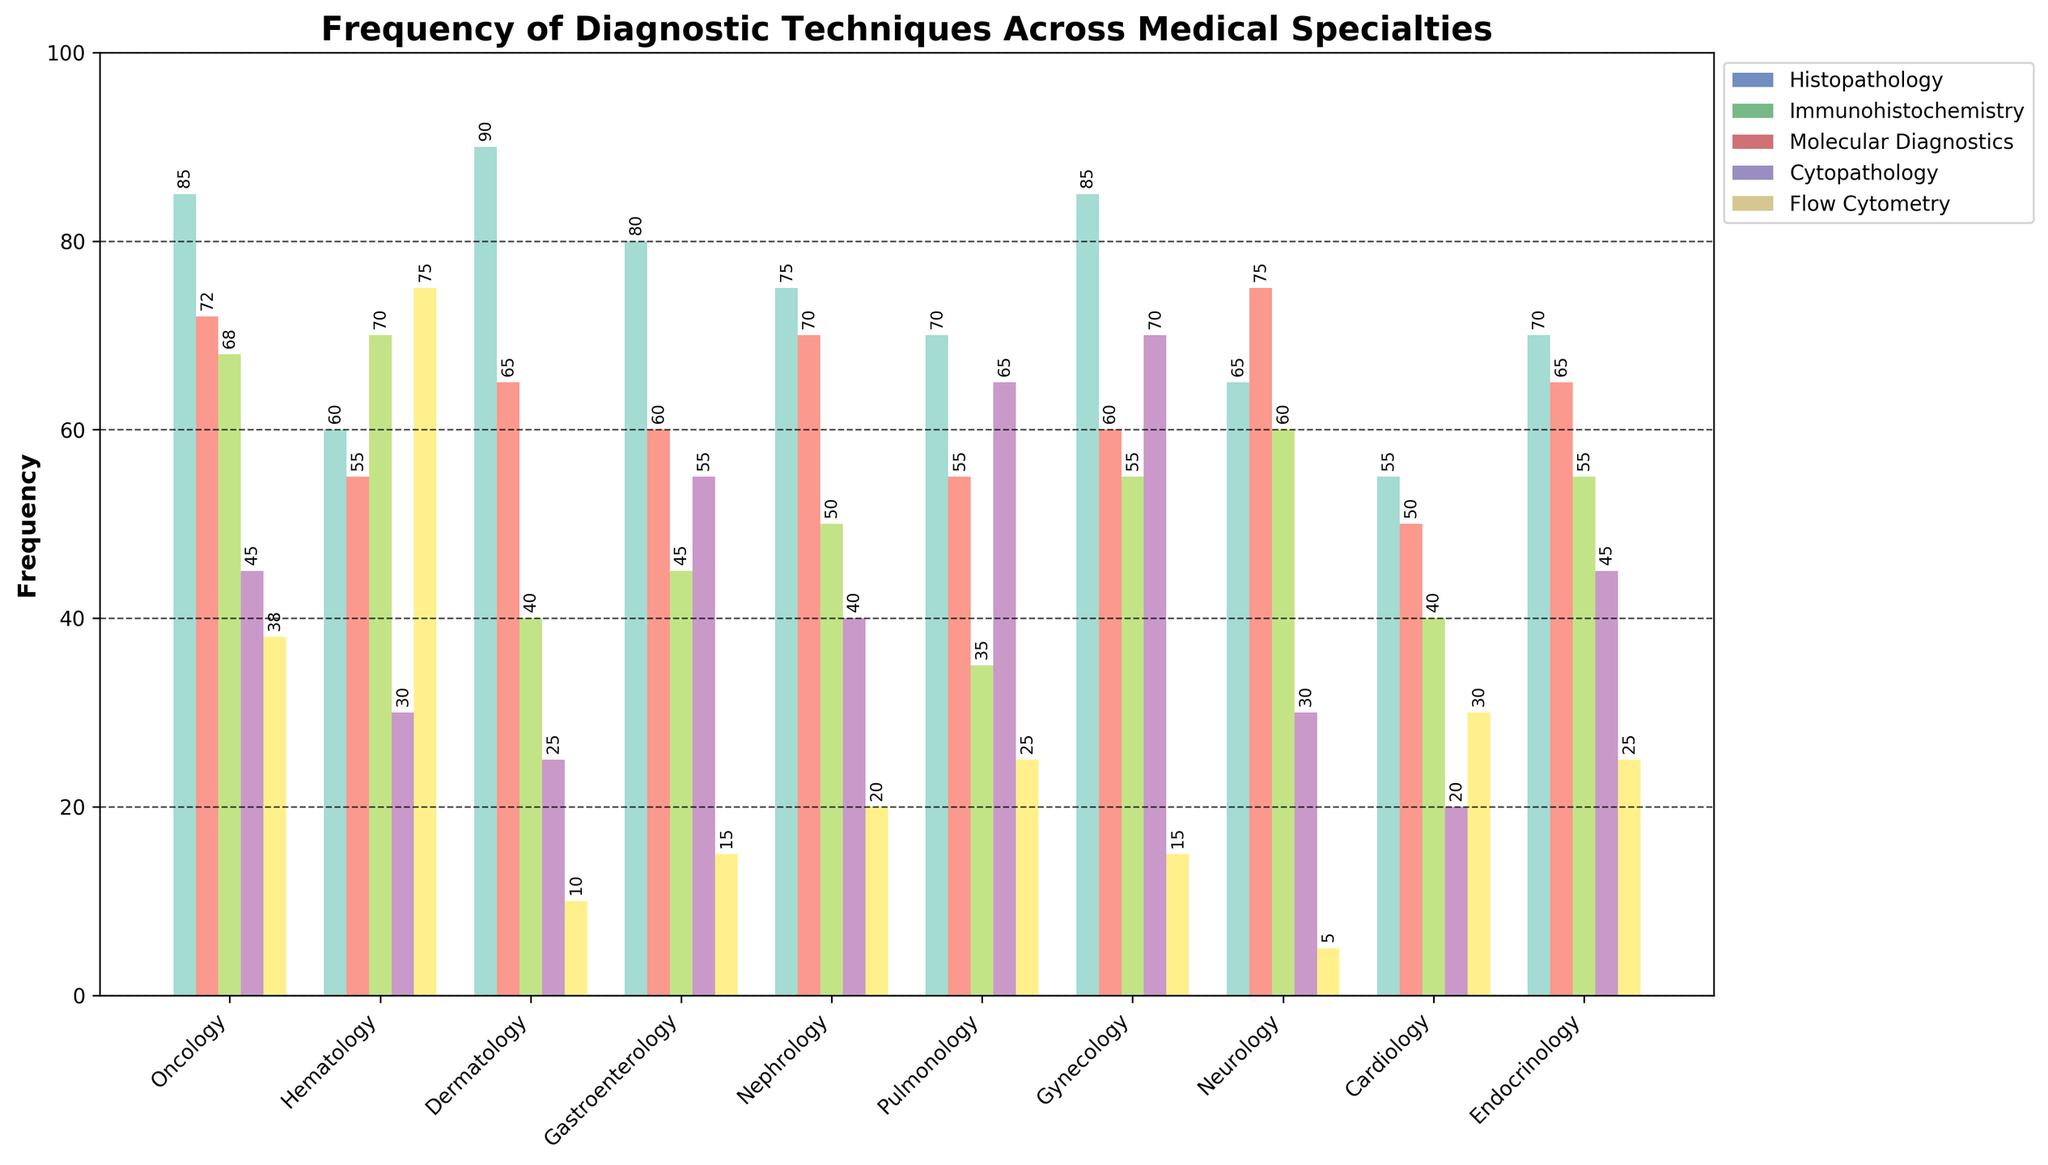Which specialty uses Immunohistochemistry most frequently? By observing the tallest bar in the Immunohistochemistry group, we see that Neurology has the highest frequency with 75.
Answer: Neurology Which diagnostic technique has the lowest frequency in Dermatology? By checking the height of the bars for Dermatology, Flow Cytometry has the shortest bar with a frequency of 10.
Answer: Flow Cytometry How does the frequency of Molecular Diagnostics in Hematology compare to its frequency in Oncology? Hematology has a frequency of 70 for Molecular Diagnostics, and Oncology has a frequency of 68. Therefore, Hematology is slightly higher.
Answer: Hematology Which specialty has the highest combined frequency for Histopathology and Cytopathology? Sum the frequencies of Histopathology and Cytopathology for each specialty. Gynecology has the highest combined frequency (85 + 70 = 155).
Answer: Gynecology Compare the frequencies of Flow Cytometry in Hematology and Nephrology. Which one is higher and by how much? Hematology has a frequency of 75, and Nephrology has a frequency of 20. The difference is 75 - 20 = 55.
Answer: Hematology by 55 What is the average frequency of Histopathology across all specialties? Sum the frequencies of Histopathology across all specialties (85 + 60 + 90 + 80 + 75 + 70 + 85 + 65 + 55 + 70 = 735) and divide by the number of specialties (10): 735 / 10 = 73.5.
Answer: 73.5 Which specialty has the most diverse use of diagnostic techniques (i.e., the smallest difference between the highest and lowest frequencies)? Calculate the difference between the highest and lowest frequencies for each specialty. Cardiology has the smallest difference (55 - 20 = 35).
Answer: Cardiology Is there any specialty where the frequency of Immunohistochemistry is exactly equal to Cytopathology? By examining both columns, Gynecology has a frequency of 60 for both Immunohistochemistry and Cytopathology.
Answer: Gynecology In which specialty does Flow Cytometry have the lowest frequency? By looking at the shortest bar in the Flow Cytometry group, Neurology has the lowest frequency with 5.
Answer: Neurology What is the combined frequency of all diagnostic techniques in Oncology? Sum the frequencies of all techniques in Oncology (85 + 72 + 68 + 45 + 38 = 308).
Answer: 308 